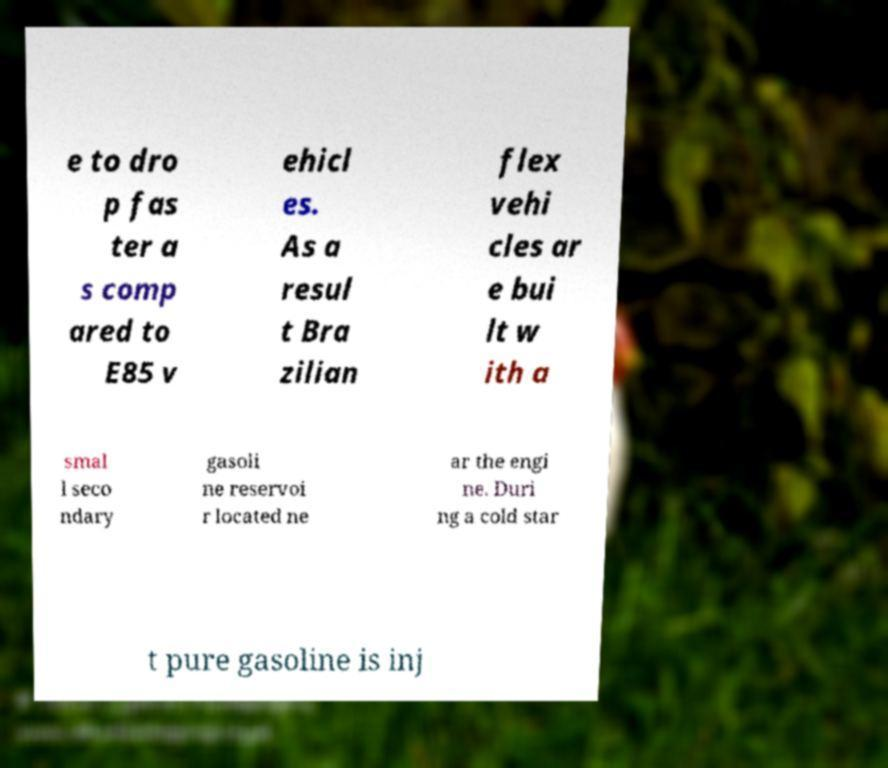Can you read and provide the text displayed in the image?This photo seems to have some interesting text. Can you extract and type it out for me? e to dro p fas ter a s comp ared to E85 v ehicl es. As a resul t Bra zilian flex vehi cles ar e bui lt w ith a smal l seco ndary gasoli ne reservoi r located ne ar the engi ne. Duri ng a cold star t pure gasoline is inj 